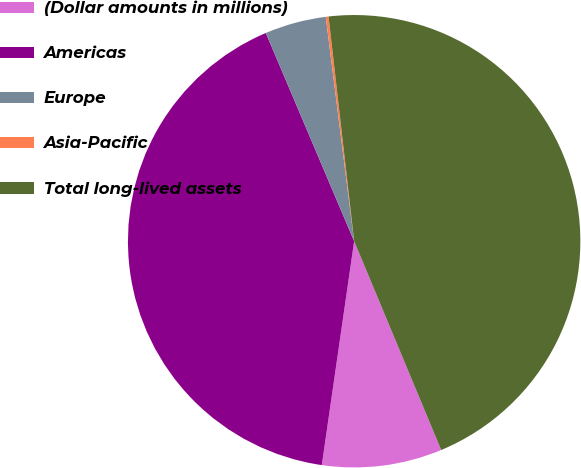Convert chart to OTSL. <chart><loc_0><loc_0><loc_500><loc_500><pie_chart><fcel>(Dollar amounts in millions)<fcel>Americas<fcel>Europe<fcel>Asia-Pacific<fcel>Total long-lived assets<nl><fcel>8.57%<fcel>41.33%<fcel>4.38%<fcel>0.2%<fcel>45.52%<nl></chart> 